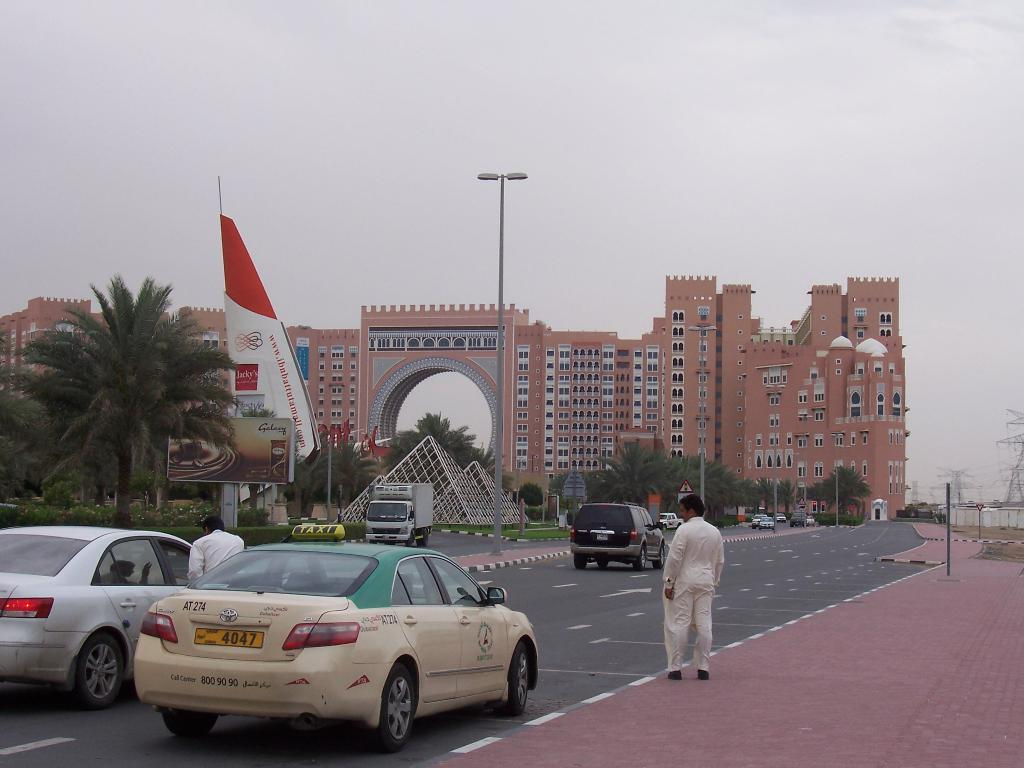<image>
Describe the image concisely. a license plate with 4047 on the back of it 